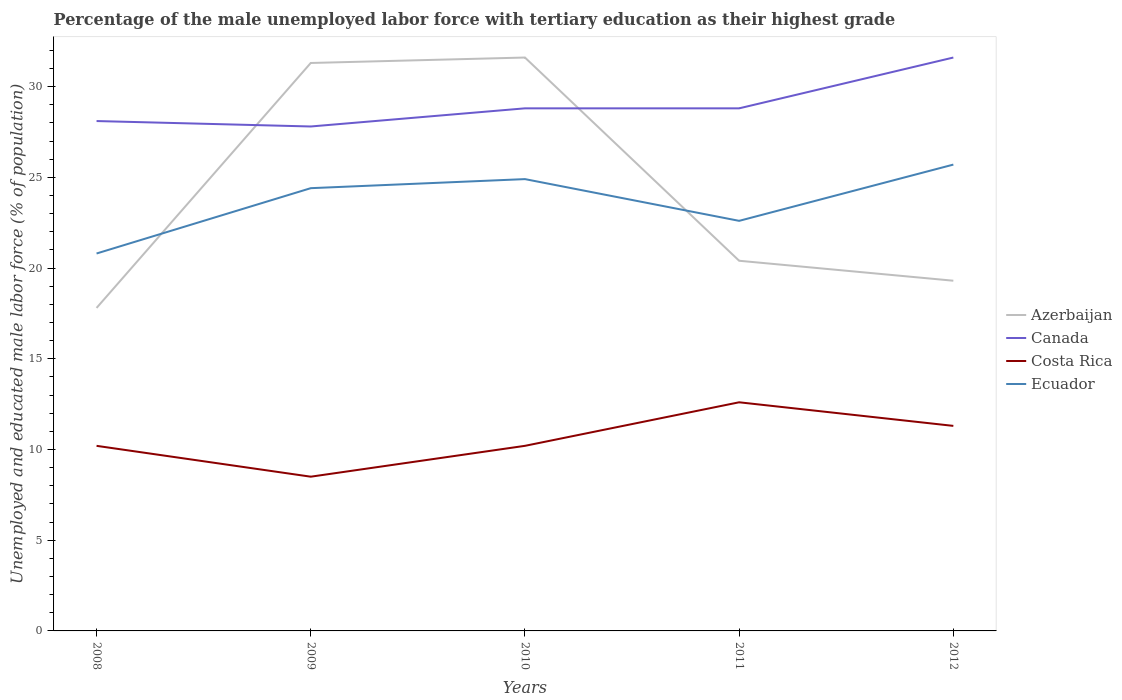How many different coloured lines are there?
Your response must be concise. 4. Across all years, what is the maximum percentage of the unemployed male labor force with tertiary education in Ecuador?
Ensure brevity in your answer.  20.8. What is the difference between the highest and the second highest percentage of the unemployed male labor force with tertiary education in Costa Rica?
Provide a short and direct response. 4.1. How many lines are there?
Offer a very short reply. 4. How many years are there in the graph?
Provide a succinct answer. 5. Are the values on the major ticks of Y-axis written in scientific E-notation?
Your response must be concise. No. Where does the legend appear in the graph?
Your response must be concise. Center right. How are the legend labels stacked?
Give a very brief answer. Vertical. What is the title of the graph?
Make the answer very short. Percentage of the male unemployed labor force with tertiary education as their highest grade. Does "Myanmar" appear as one of the legend labels in the graph?
Your answer should be very brief. No. What is the label or title of the X-axis?
Make the answer very short. Years. What is the label or title of the Y-axis?
Provide a succinct answer. Unemployed and educated male labor force (% of population). What is the Unemployed and educated male labor force (% of population) in Azerbaijan in 2008?
Your answer should be very brief. 17.8. What is the Unemployed and educated male labor force (% of population) of Canada in 2008?
Give a very brief answer. 28.1. What is the Unemployed and educated male labor force (% of population) in Costa Rica in 2008?
Your answer should be very brief. 10.2. What is the Unemployed and educated male labor force (% of population) of Ecuador in 2008?
Provide a succinct answer. 20.8. What is the Unemployed and educated male labor force (% of population) of Azerbaijan in 2009?
Your answer should be compact. 31.3. What is the Unemployed and educated male labor force (% of population) of Canada in 2009?
Your answer should be compact. 27.8. What is the Unemployed and educated male labor force (% of population) of Costa Rica in 2009?
Provide a succinct answer. 8.5. What is the Unemployed and educated male labor force (% of population) of Ecuador in 2009?
Ensure brevity in your answer.  24.4. What is the Unemployed and educated male labor force (% of population) in Azerbaijan in 2010?
Your response must be concise. 31.6. What is the Unemployed and educated male labor force (% of population) of Canada in 2010?
Make the answer very short. 28.8. What is the Unemployed and educated male labor force (% of population) of Costa Rica in 2010?
Keep it short and to the point. 10.2. What is the Unemployed and educated male labor force (% of population) of Ecuador in 2010?
Keep it short and to the point. 24.9. What is the Unemployed and educated male labor force (% of population) of Azerbaijan in 2011?
Offer a terse response. 20.4. What is the Unemployed and educated male labor force (% of population) in Canada in 2011?
Keep it short and to the point. 28.8. What is the Unemployed and educated male labor force (% of population) of Costa Rica in 2011?
Offer a terse response. 12.6. What is the Unemployed and educated male labor force (% of population) in Ecuador in 2011?
Your answer should be very brief. 22.6. What is the Unemployed and educated male labor force (% of population) of Azerbaijan in 2012?
Your response must be concise. 19.3. What is the Unemployed and educated male labor force (% of population) of Canada in 2012?
Offer a very short reply. 31.6. What is the Unemployed and educated male labor force (% of population) in Costa Rica in 2012?
Your answer should be compact. 11.3. What is the Unemployed and educated male labor force (% of population) of Ecuador in 2012?
Offer a terse response. 25.7. Across all years, what is the maximum Unemployed and educated male labor force (% of population) of Azerbaijan?
Your answer should be compact. 31.6. Across all years, what is the maximum Unemployed and educated male labor force (% of population) of Canada?
Keep it short and to the point. 31.6. Across all years, what is the maximum Unemployed and educated male labor force (% of population) in Costa Rica?
Provide a succinct answer. 12.6. Across all years, what is the maximum Unemployed and educated male labor force (% of population) of Ecuador?
Your answer should be very brief. 25.7. Across all years, what is the minimum Unemployed and educated male labor force (% of population) in Azerbaijan?
Offer a very short reply. 17.8. Across all years, what is the minimum Unemployed and educated male labor force (% of population) of Canada?
Offer a very short reply. 27.8. Across all years, what is the minimum Unemployed and educated male labor force (% of population) in Costa Rica?
Provide a short and direct response. 8.5. Across all years, what is the minimum Unemployed and educated male labor force (% of population) in Ecuador?
Give a very brief answer. 20.8. What is the total Unemployed and educated male labor force (% of population) of Azerbaijan in the graph?
Keep it short and to the point. 120.4. What is the total Unemployed and educated male labor force (% of population) in Canada in the graph?
Offer a terse response. 145.1. What is the total Unemployed and educated male labor force (% of population) of Costa Rica in the graph?
Offer a terse response. 52.8. What is the total Unemployed and educated male labor force (% of population) of Ecuador in the graph?
Ensure brevity in your answer.  118.4. What is the difference between the Unemployed and educated male labor force (% of population) in Azerbaijan in 2008 and that in 2009?
Give a very brief answer. -13.5. What is the difference between the Unemployed and educated male labor force (% of population) of Costa Rica in 2008 and that in 2009?
Your answer should be compact. 1.7. What is the difference between the Unemployed and educated male labor force (% of population) of Costa Rica in 2008 and that in 2010?
Offer a very short reply. 0. What is the difference between the Unemployed and educated male labor force (% of population) of Ecuador in 2008 and that in 2010?
Provide a succinct answer. -4.1. What is the difference between the Unemployed and educated male labor force (% of population) in Azerbaijan in 2008 and that in 2011?
Offer a terse response. -2.6. What is the difference between the Unemployed and educated male labor force (% of population) in Canada in 2008 and that in 2011?
Offer a terse response. -0.7. What is the difference between the Unemployed and educated male labor force (% of population) in Costa Rica in 2008 and that in 2011?
Your response must be concise. -2.4. What is the difference between the Unemployed and educated male labor force (% of population) of Costa Rica in 2008 and that in 2012?
Your response must be concise. -1.1. What is the difference between the Unemployed and educated male labor force (% of population) of Azerbaijan in 2009 and that in 2010?
Provide a succinct answer. -0.3. What is the difference between the Unemployed and educated male labor force (% of population) in Costa Rica in 2009 and that in 2010?
Offer a terse response. -1.7. What is the difference between the Unemployed and educated male labor force (% of population) in Ecuador in 2009 and that in 2010?
Ensure brevity in your answer.  -0.5. What is the difference between the Unemployed and educated male labor force (% of population) in Canada in 2009 and that in 2011?
Provide a succinct answer. -1. What is the difference between the Unemployed and educated male labor force (% of population) of Azerbaijan in 2009 and that in 2012?
Provide a short and direct response. 12. What is the difference between the Unemployed and educated male labor force (% of population) of Canada in 2009 and that in 2012?
Provide a short and direct response. -3.8. What is the difference between the Unemployed and educated male labor force (% of population) in Costa Rica in 2009 and that in 2012?
Your answer should be compact. -2.8. What is the difference between the Unemployed and educated male labor force (% of population) of Ecuador in 2009 and that in 2012?
Offer a terse response. -1.3. What is the difference between the Unemployed and educated male labor force (% of population) in Ecuador in 2010 and that in 2011?
Make the answer very short. 2.3. What is the difference between the Unemployed and educated male labor force (% of population) in Canada in 2010 and that in 2012?
Provide a succinct answer. -2.8. What is the difference between the Unemployed and educated male labor force (% of population) of Azerbaijan in 2011 and that in 2012?
Keep it short and to the point. 1.1. What is the difference between the Unemployed and educated male labor force (% of population) in Azerbaijan in 2008 and the Unemployed and educated male labor force (% of population) in Costa Rica in 2009?
Provide a short and direct response. 9.3. What is the difference between the Unemployed and educated male labor force (% of population) in Canada in 2008 and the Unemployed and educated male labor force (% of population) in Costa Rica in 2009?
Offer a terse response. 19.6. What is the difference between the Unemployed and educated male labor force (% of population) of Canada in 2008 and the Unemployed and educated male labor force (% of population) of Ecuador in 2009?
Provide a succinct answer. 3.7. What is the difference between the Unemployed and educated male labor force (% of population) of Azerbaijan in 2008 and the Unemployed and educated male labor force (% of population) of Costa Rica in 2010?
Ensure brevity in your answer.  7.6. What is the difference between the Unemployed and educated male labor force (% of population) of Canada in 2008 and the Unemployed and educated male labor force (% of population) of Costa Rica in 2010?
Your answer should be compact. 17.9. What is the difference between the Unemployed and educated male labor force (% of population) of Costa Rica in 2008 and the Unemployed and educated male labor force (% of population) of Ecuador in 2010?
Provide a succinct answer. -14.7. What is the difference between the Unemployed and educated male labor force (% of population) in Canada in 2008 and the Unemployed and educated male labor force (% of population) in Costa Rica in 2011?
Offer a very short reply. 15.5. What is the difference between the Unemployed and educated male labor force (% of population) of Canada in 2008 and the Unemployed and educated male labor force (% of population) of Ecuador in 2011?
Your response must be concise. 5.5. What is the difference between the Unemployed and educated male labor force (% of population) of Azerbaijan in 2008 and the Unemployed and educated male labor force (% of population) of Costa Rica in 2012?
Keep it short and to the point. 6.5. What is the difference between the Unemployed and educated male labor force (% of population) in Azerbaijan in 2008 and the Unemployed and educated male labor force (% of population) in Ecuador in 2012?
Offer a terse response. -7.9. What is the difference between the Unemployed and educated male labor force (% of population) of Costa Rica in 2008 and the Unemployed and educated male labor force (% of population) of Ecuador in 2012?
Your answer should be compact. -15.5. What is the difference between the Unemployed and educated male labor force (% of population) of Azerbaijan in 2009 and the Unemployed and educated male labor force (% of population) of Canada in 2010?
Provide a short and direct response. 2.5. What is the difference between the Unemployed and educated male labor force (% of population) of Azerbaijan in 2009 and the Unemployed and educated male labor force (% of population) of Costa Rica in 2010?
Give a very brief answer. 21.1. What is the difference between the Unemployed and educated male labor force (% of population) of Canada in 2009 and the Unemployed and educated male labor force (% of population) of Costa Rica in 2010?
Your answer should be compact. 17.6. What is the difference between the Unemployed and educated male labor force (% of population) in Canada in 2009 and the Unemployed and educated male labor force (% of population) in Ecuador in 2010?
Provide a short and direct response. 2.9. What is the difference between the Unemployed and educated male labor force (% of population) of Costa Rica in 2009 and the Unemployed and educated male labor force (% of population) of Ecuador in 2010?
Your response must be concise. -16.4. What is the difference between the Unemployed and educated male labor force (% of population) of Azerbaijan in 2009 and the Unemployed and educated male labor force (% of population) of Canada in 2011?
Provide a short and direct response. 2.5. What is the difference between the Unemployed and educated male labor force (% of population) of Azerbaijan in 2009 and the Unemployed and educated male labor force (% of population) of Ecuador in 2011?
Offer a very short reply. 8.7. What is the difference between the Unemployed and educated male labor force (% of population) of Costa Rica in 2009 and the Unemployed and educated male labor force (% of population) of Ecuador in 2011?
Offer a terse response. -14.1. What is the difference between the Unemployed and educated male labor force (% of population) in Azerbaijan in 2009 and the Unemployed and educated male labor force (% of population) in Canada in 2012?
Keep it short and to the point. -0.3. What is the difference between the Unemployed and educated male labor force (% of population) in Azerbaijan in 2009 and the Unemployed and educated male labor force (% of population) in Costa Rica in 2012?
Offer a terse response. 20. What is the difference between the Unemployed and educated male labor force (% of population) of Canada in 2009 and the Unemployed and educated male labor force (% of population) of Ecuador in 2012?
Your answer should be compact. 2.1. What is the difference between the Unemployed and educated male labor force (% of population) in Costa Rica in 2009 and the Unemployed and educated male labor force (% of population) in Ecuador in 2012?
Give a very brief answer. -17.2. What is the difference between the Unemployed and educated male labor force (% of population) in Azerbaijan in 2010 and the Unemployed and educated male labor force (% of population) in Canada in 2011?
Your answer should be very brief. 2.8. What is the difference between the Unemployed and educated male labor force (% of population) of Azerbaijan in 2010 and the Unemployed and educated male labor force (% of population) of Ecuador in 2011?
Provide a succinct answer. 9. What is the difference between the Unemployed and educated male labor force (% of population) of Canada in 2010 and the Unemployed and educated male labor force (% of population) of Costa Rica in 2011?
Ensure brevity in your answer.  16.2. What is the difference between the Unemployed and educated male labor force (% of population) of Costa Rica in 2010 and the Unemployed and educated male labor force (% of population) of Ecuador in 2011?
Make the answer very short. -12.4. What is the difference between the Unemployed and educated male labor force (% of population) in Azerbaijan in 2010 and the Unemployed and educated male labor force (% of population) in Costa Rica in 2012?
Your answer should be compact. 20.3. What is the difference between the Unemployed and educated male labor force (% of population) of Azerbaijan in 2010 and the Unemployed and educated male labor force (% of population) of Ecuador in 2012?
Make the answer very short. 5.9. What is the difference between the Unemployed and educated male labor force (% of population) in Canada in 2010 and the Unemployed and educated male labor force (% of population) in Costa Rica in 2012?
Offer a terse response. 17.5. What is the difference between the Unemployed and educated male labor force (% of population) in Costa Rica in 2010 and the Unemployed and educated male labor force (% of population) in Ecuador in 2012?
Ensure brevity in your answer.  -15.5. What is the difference between the Unemployed and educated male labor force (% of population) of Azerbaijan in 2011 and the Unemployed and educated male labor force (% of population) of Costa Rica in 2012?
Your answer should be very brief. 9.1. What is the difference between the Unemployed and educated male labor force (% of population) in Costa Rica in 2011 and the Unemployed and educated male labor force (% of population) in Ecuador in 2012?
Ensure brevity in your answer.  -13.1. What is the average Unemployed and educated male labor force (% of population) in Azerbaijan per year?
Give a very brief answer. 24.08. What is the average Unemployed and educated male labor force (% of population) of Canada per year?
Make the answer very short. 29.02. What is the average Unemployed and educated male labor force (% of population) in Costa Rica per year?
Ensure brevity in your answer.  10.56. What is the average Unemployed and educated male labor force (% of population) in Ecuador per year?
Make the answer very short. 23.68. In the year 2008, what is the difference between the Unemployed and educated male labor force (% of population) in Azerbaijan and Unemployed and educated male labor force (% of population) in Canada?
Offer a terse response. -10.3. In the year 2008, what is the difference between the Unemployed and educated male labor force (% of population) in Azerbaijan and Unemployed and educated male labor force (% of population) in Costa Rica?
Keep it short and to the point. 7.6. In the year 2009, what is the difference between the Unemployed and educated male labor force (% of population) in Azerbaijan and Unemployed and educated male labor force (% of population) in Canada?
Your response must be concise. 3.5. In the year 2009, what is the difference between the Unemployed and educated male labor force (% of population) of Azerbaijan and Unemployed and educated male labor force (% of population) of Costa Rica?
Your response must be concise. 22.8. In the year 2009, what is the difference between the Unemployed and educated male labor force (% of population) in Canada and Unemployed and educated male labor force (% of population) in Costa Rica?
Offer a very short reply. 19.3. In the year 2009, what is the difference between the Unemployed and educated male labor force (% of population) in Canada and Unemployed and educated male labor force (% of population) in Ecuador?
Your answer should be compact. 3.4. In the year 2009, what is the difference between the Unemployed and educated male labor force (% of population) in Costa Rica and Unemployed and educated male labor force (% of population) in Ecuador?
Ensure brevity in your answer.  -15.9. In the year 2010, what is the difference between the Unemployed and educated male labor force (% of population) in Azerbaijan and Unemployed and educated male labor force (% of population) in Costa Rica?
Your response must be concise. 21.4. In the year 2010, what is the difference between the Unemployed and educated male labor force (% of population) of Canada and Unemployed and educated male labor force (% of population) of Ecuador?
Make the answer very short. 3.9. In the year 2010, what is the difference between the Unemployed and educated male labor force (% of population) of Costa Rica and Unemployed and educated male labor force (% of population) of Ecuador?
Ensure brevity in your answer.  -14.7. In the year 2011, what is the difference between the Unemployed and educated male labor force (% of population) of Azerbaijan and Unemployed and educated male labor force (% of population) of Canada?
Your response must be concise. -8.4. In the year 2011, what is the difference between the Unemployed and educated male labor force (% of population) of Azerbaijan and Unemployed and educated male labor force (% of population) of Ecuador?
Your response must be concise. -2.2. In the year 2011, what is the difference between the Unemployed and educated male labor force (% of population) in Canada and Unemployed and educated male labor force (% of population) in Costa Rica?
Your answer should be very brief. 16.2. In the year 2011, what is the difference between the Unemployed and educated male labor force (% of population) in Canada and Unemployed and educated male labor force (% of population) in Ecuador?
Your response must be concise. 6.2. In the year 2011, what is the difference between the Unemployed and educated male labor force (% of population) of Costa Rica and Unemployed and educated male labor force (% of population) of Ecuador?
Offer a very short reply. -10. In the year 2012, what is the difference between the Unemployed and educated male labor force (% of population) in Azerbaijan and Unemployed and educated male labor force (% of population) in Canada?
Provide a short and direct response. -12.3. In the year 2012, what is the difference between the Unemployed and educated male labor force (% of population) of Canada and Unemployed and educated male labor force (% of population) of Costa Rica?
Offer a terse response. 20.3. In the year 2012, what is the difference between the Unemployed and educated male labor force (% of population) of Costa Rica and Unemployed and educated male labor force (% of population) of Ecuador?
Your answer should be compact. -14.4. What is the ratio of the Unemployed and educated male labor force (% of population) in Azerbaijan in 2008 to that in 2009?
Offer a very short reply. 0.57. What is the ratio of the Unemployed and educated male labor force (% of population) in Canada in 2008 to that in 2009?
Keep it short and to the point. 1.01. What is the ratio of the Unemployed and educated male labor force (% of population) of Ecuador in 2008 to that in 2009?
Keep it short and to the point. 0.85. What is the ratio of the Unemployed and educated male labor force (% of population) in Azerbaijan in 2008 to that in 2010?
Your answer should be compact. 0.56. What is the ratio of the Unemployed and educated male labor force (% of population) in Canada in 2008 to that in 2010?
Your response must be concise. 0.98. What is the ratio of the Unemployed and educated male labor force (% of population) in Ecuador in 2008 to that in 2010?
Your answer should be compact. 0.84. What is the ratio of the Unemployed and educated male labor force (% of population) in Azerbaijan in 2008 to that in 2011?
Your answer should be compact. 0.87. What is the ratio of the Unemployed and educated male labor force (% of population) of Canada in 2008 to that in 2011?
Offer a terse response. 0.98. What is the ratio of the Unemployed and educated male labor force (% of population) in Costa Rica in 2008 to that in 2011?
Offer a very short reply. 0.81. What is the ratio of the Unemployed and educated male labor force (% of population) of Ecuador in 2008 to that in 2011?
Keep it short and to the point. 0.92. What is the ratio of the Unemployed and educated male labor force (% of population) of Azerbaijan in 2008 to that in 2012?
Your answer should be compact. 0.92. What is the ratio of the Unemployed and educated male labor force (% of population) of Canada in 2008 to that in 2012?
Make the answer very short. 0.89. What is the ratio of the Unemployed and educated male labor force (% of population) of Costa Rica in 2008 to that in 2012?
Offer a terse response. 0.9. What is the ratio of the Unemployed and educated male labor force (% of population) of Ecuador in 2008 to that in 2012?
Provide a short and direct response. 0.81. What is the ratio of the Unemployed and educated male labor force (% of population) in Canada in 2009 to that in 2010?
Make the answer very short. 0.97. What is the ratio of the Unemployed and educated male labor force (% of population) in Ecuador in 2009 to that in 2010?
Your answer should be compact. 0.98. What is the ratio of the Unemployed and educated male labor force (% of population) of Azerbaijan in 2009 to that in 2011?
Your answer should be very brief. 1.53. What is the ratio of the Unemployed and educated male labor force (% of population) of Canada in 2009 to that in 2011?
Make the answer very short. 0.97. What is the ratio of the Unemployed and educated male labor force (% of population) of Costa Rica in 2009 to that in 2011?
Provide a succinct answer. 0.67. What is the ratio of the Unemployed and educated male labor force (% of population) of Ecuador in 2009 to that in 2011?
Give a very brief answer. 1.08. What is the ratio of the Unemployed and educated male labor force (% of population) of Azerbaijan in 2009 to that in 2012?
Give a very brief answer. 1.62. What is the ratio of the Unemployed and educated male labor force (% of population) in Canada in 2009 to that in 2012?
Your answer should be very brief. 0.88. What is the ratio of the Unemployed and educated male labor force (% of population) of Costa Rica in 2009 to that in 2012?
Provide a short and direct response. 0.75. What is the ratio of the Unemployed and educated male labor force (% of population) of Ecuador in 2009 to that in 2012?
Your answer should be very brief. 0.95. What is the ratio of the Unemployed and educated male labor force (% of population) of Azerbaijan in 2010 to that in 2011?
Your response must be concise. 1.55. What is the ratio of the Unemployed and educated male labor force (% of population) in Canada in 2010 to that in 2011?
Make the answer very short. 1. What is the ratio of the Unemployed and educated male labor force (% of population) of Costa Rica in 2010 to that in 2011?
Ensure brevity in your answer.  0.81. What is the ratio of the Unemployed and educated male labor force (% of population) in Ecuador in 2010 to that in 2011?
Offer a very short reply. 1.1. What is the ratio of the Unemployed and educated male labor force (% of population) in Azerbaijan in 2010 to that in 2012?
Provide a succinct answer. 1.64. What is the ratio of the Unemployed and educated male labor force (% of population) in Canada in 2010 to that in 2012?
Your response must be concise. 0.91. What is the ratio of the Unemployed and educated male labor force (% of population) in Costa Rica in 2010 to that in 2012?
Keep it short and to the point. 0.9. What is the ratio of the Unemployed and educated male labor force (% of population) in Ecuador in 2010 to that in 2012?
Your answer should be compact. 0.97. What is the ratio of the Unemployed and educated male labor force (% of population) in Azerbaijan in 2011 to that in 2012?
Your answer should be compact. 1.06. What is the ratio of the Unemployed and educated male labor force (% of population) of Canada in 2011 to that in 2012?
Provide a short and direct response. 0.91. What is the ratio of the Unemployed and educated male labor force (% of population) of Costa Rica in 2011 to that in 2012?
Give a very brief answer. 1.11. What is the ratio of the Unemployed and educated male labor force (% of population) in Ecuador in 2011 to that in 2012?
Ensure brevity in your answer.  0.88. What is the difference between the highest and the second highest Unemployed and educated male labor force (% of population) of Azerbaijan?
Provide a succinct answer. 0.3. What is the difference between the highest and the second highest Unemployed and educated male labor force (% of population) of Costa Rica?
Keep it short and to the point. 1.3. What is the difference between the highest and the second highest Unemployed and educated male labor force (% of population) of Ecuador?
Offer a terse response. 0.8. What is the difference between the highest and the lowest Unemployed and educated male labor force (% of population) in Azerbaijan?
Provide a short and direct response. 13.8. What is the difference between the highest and the lowest Unemployed and educated male labor force (% of population) of Costa Rica?
Offer a very short reply. 4.1. What is the difference between the highest and the lowest Unemployed and educated male labor force (% of population) of Ecuador?
Provide a succinct answer. 4.9. 